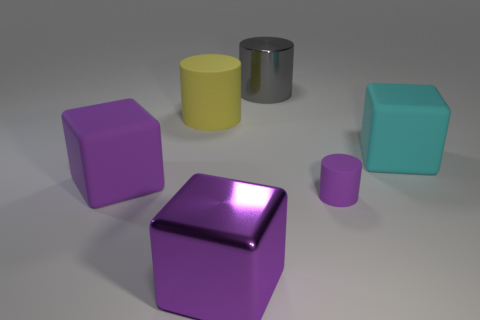Add 1 small purple things. How many objects exist? 7 Subtract all big cyan matte blocks. How many blocks are left? 2 Subtract all cyan blocks. How many blocks are left? 2 Subtract 1 cylinders. How many cylinders are left? 2 Subtract all gray cubes. Subtract all green balls. How many cubes are left? 3 Subtract all purple cylinders. How many purple cubes are left? 2 Subtract all yellow matte cubes. Subtract all yellow cylinders. How many objects are left? 5 Add 6 small purple objects. How many small purple objects are left? 7 Add 2 shiny blocks. How many shiny blocks exist? 3 Subtract 0 red balls. How many objects are left? 6 